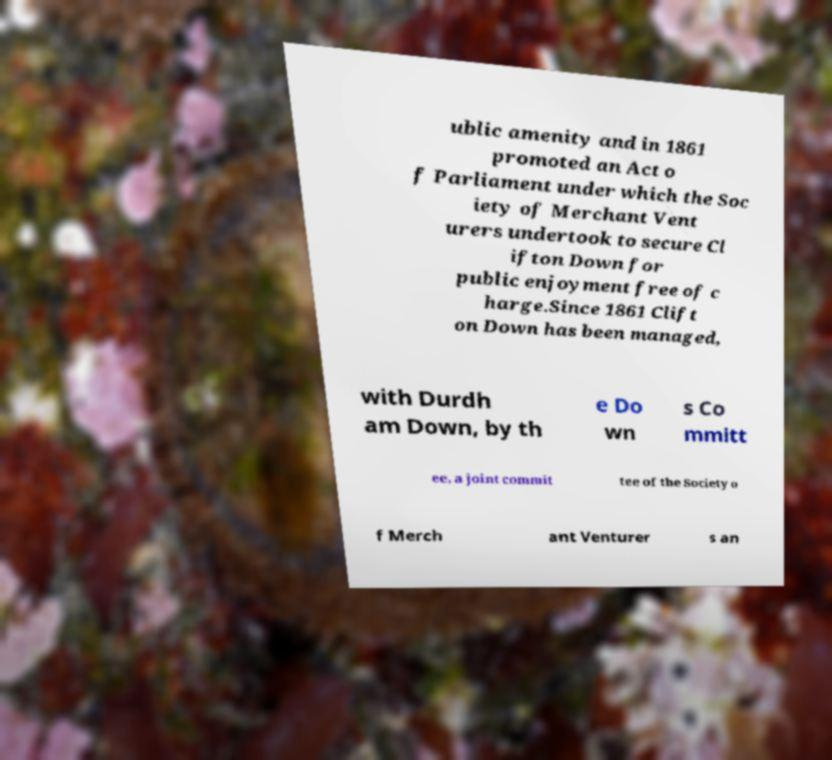What messages or text are displayed in this image? I need them in a readable, typed format. ublic amenity and in 1861 promoted an Act o f Parliament under which the Soc iety of Merchant Vent urers undertook to secure Cl ifton Down for public enjoyment free of c harge.Since 1861 Clift on Down has been managed, with Durdh am Down, by th e Do wn s Co mmitt ee, a joint commit tee of the Society o f Merch ant Venturer s an 